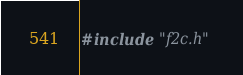<code> <loc_0><loc_0><loc_500><loc_500><_C_>#include "f2c.h"
</code> 